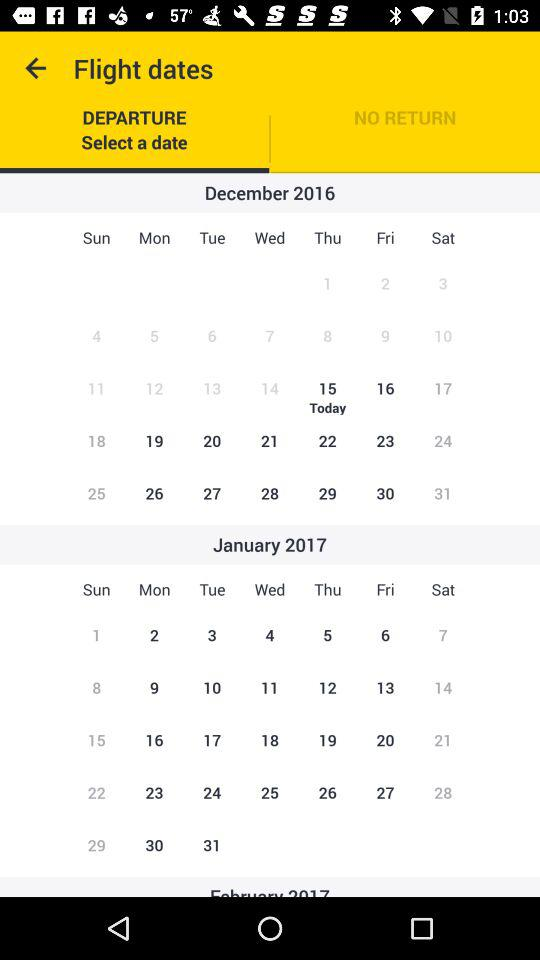What is the day on December 15? The day on December 15 is Thursday. 